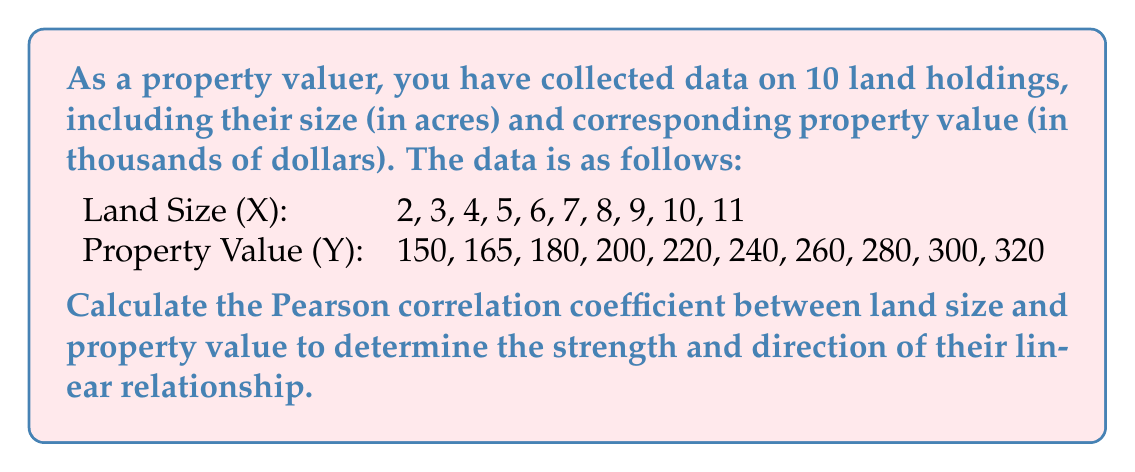Can you solve this math problem? To calculate the Pearson correlation coefficient (r) between land size (X) and property value (Y), we'll use the following formula:

$$ r = \frac{n\sum xy - \sum x \sum y}{\sqrt{[n\sum x^2 - (\sum x)^2][n\sum y^2 - (\sum y)^2]}} $$

Where:
n = number of pairs of data
x = land size
y = property value

Step 1: Calculate the required sums:
$\sum x = 65$
$\sum y = 2315$
$\sum xy = 16775$
$\sum x^2 = 505$
$\sum y^2 = 565725$

Step 2: Calculate $n\sum xy$ and $\sum x \sum y$:
$n\sum xy = 10 \times 16775 = 167750$
$\sum x \sum y = 65 \times 2315 = 150475$

Step 3: Calculate $n\sum x^2$ and $(\sum x)^2$:
$n\sum x^2 = 10 \times 505 = 5050$
$(\sum x)^2 = 65^2 = 4225$

Step 4: Calculate $n\sum y^2$ and $(\sum y)^2$:
$n\sum y^2 = 10 \times 565725 = 5657250$
$(\sum y)^2 = 2315^2 = 5359225$

Step 5: Substitute these values into the correlation coefficient formula:

$$ r = \frac{167750 - 150475}{\sqrt{(5050 - 4225)(5657250 - 5359225)}} $$

$$ r = \frac{17275}{\sqrt{825 \times 298025}} $$

$$ r = \frac{17275}{\sqrt{245870625}} $$

$$ r = \frac{17275}{15680.90} $$

$$ r \approx 0.9997 $$
Answer: The Pearson correlation coefficient between land size and property value is approximately 0.9997. 